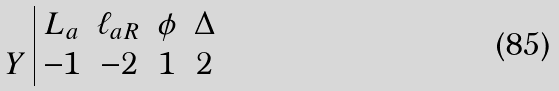<formula> <loc_0><loc_0><loc_500><loc_500>\begin{array} { l | c c c c } & L _ { a } & \ell _ { a R } & \phi & \Delta \\ Y & - 1 & - 2 & 1 & 2 \end{array}</formula> 